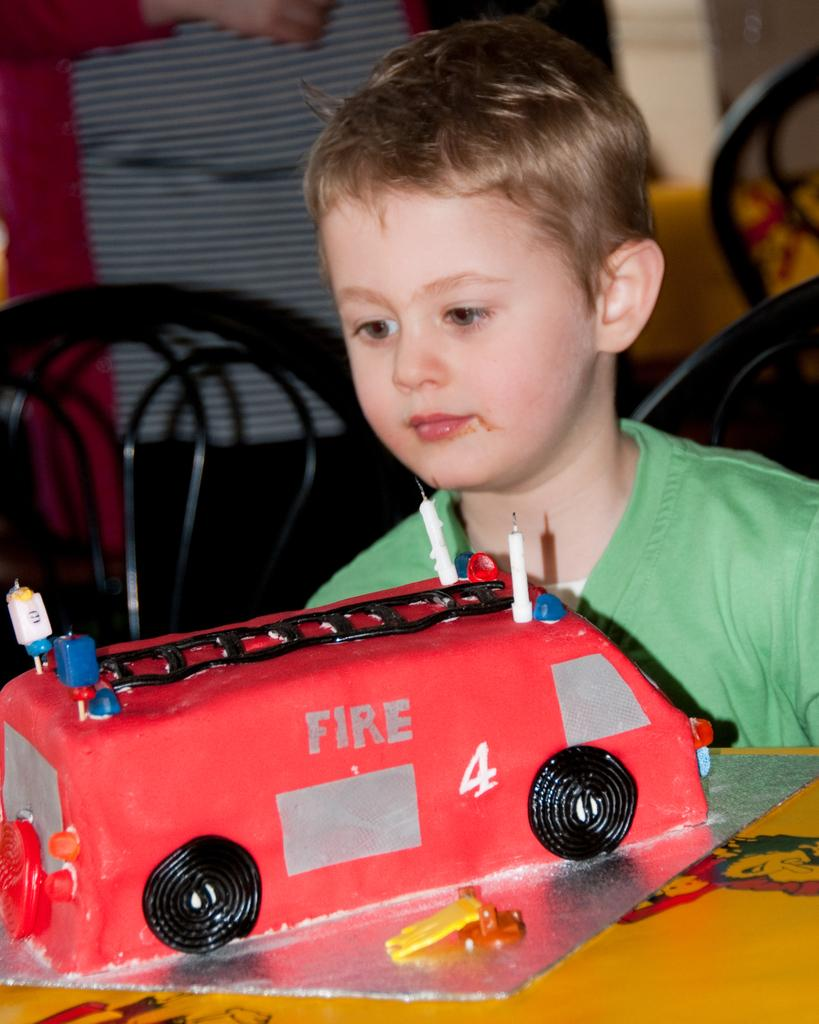Who is the main subject in the image? There is a boy in the image. What is the boy wearing? The boy is wearing a green t-shirt. What is in front of the boy? There is a cake in front of the boy. What type of chairs are visible behind the boy? There are black chairs behind the boy. Are there any other people present in the image? Yes, there is at least one person present behind the black chairs. What type of net can be seen hanging from the ceiling in the image? There is no net hanging from the ceiling in the image. Is there a cactus visible in the image? No, there is no cactus present in the image. 